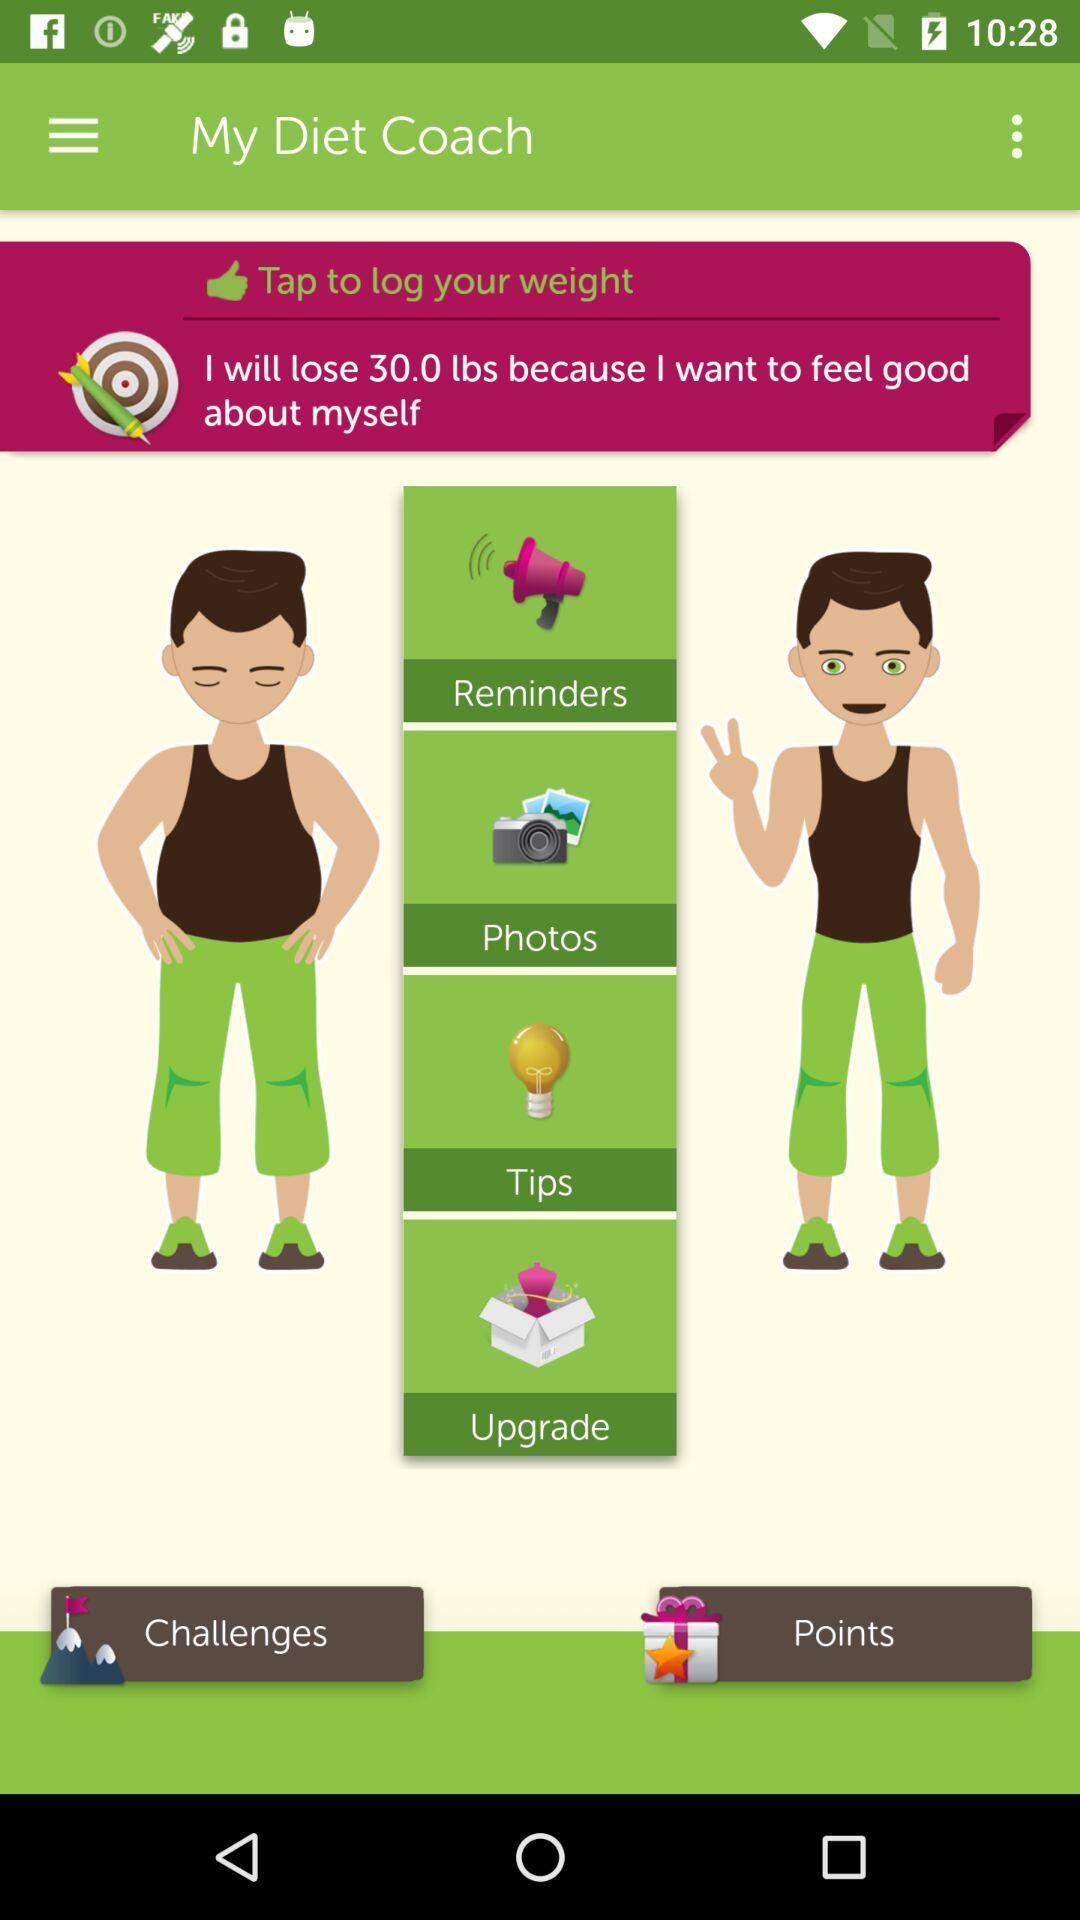What is the application name? The application name is "My Diet Coach". 